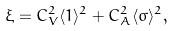<formula> <loc_0><loc_0><loc_500><loc_500>\xi = C ^ { 2 } _ { V } \langle 1 \rangle ^ { 2 } + C ^ { 2 } _ { A } \langle \sigma \rangle ^ { 2 } ,</formula> 